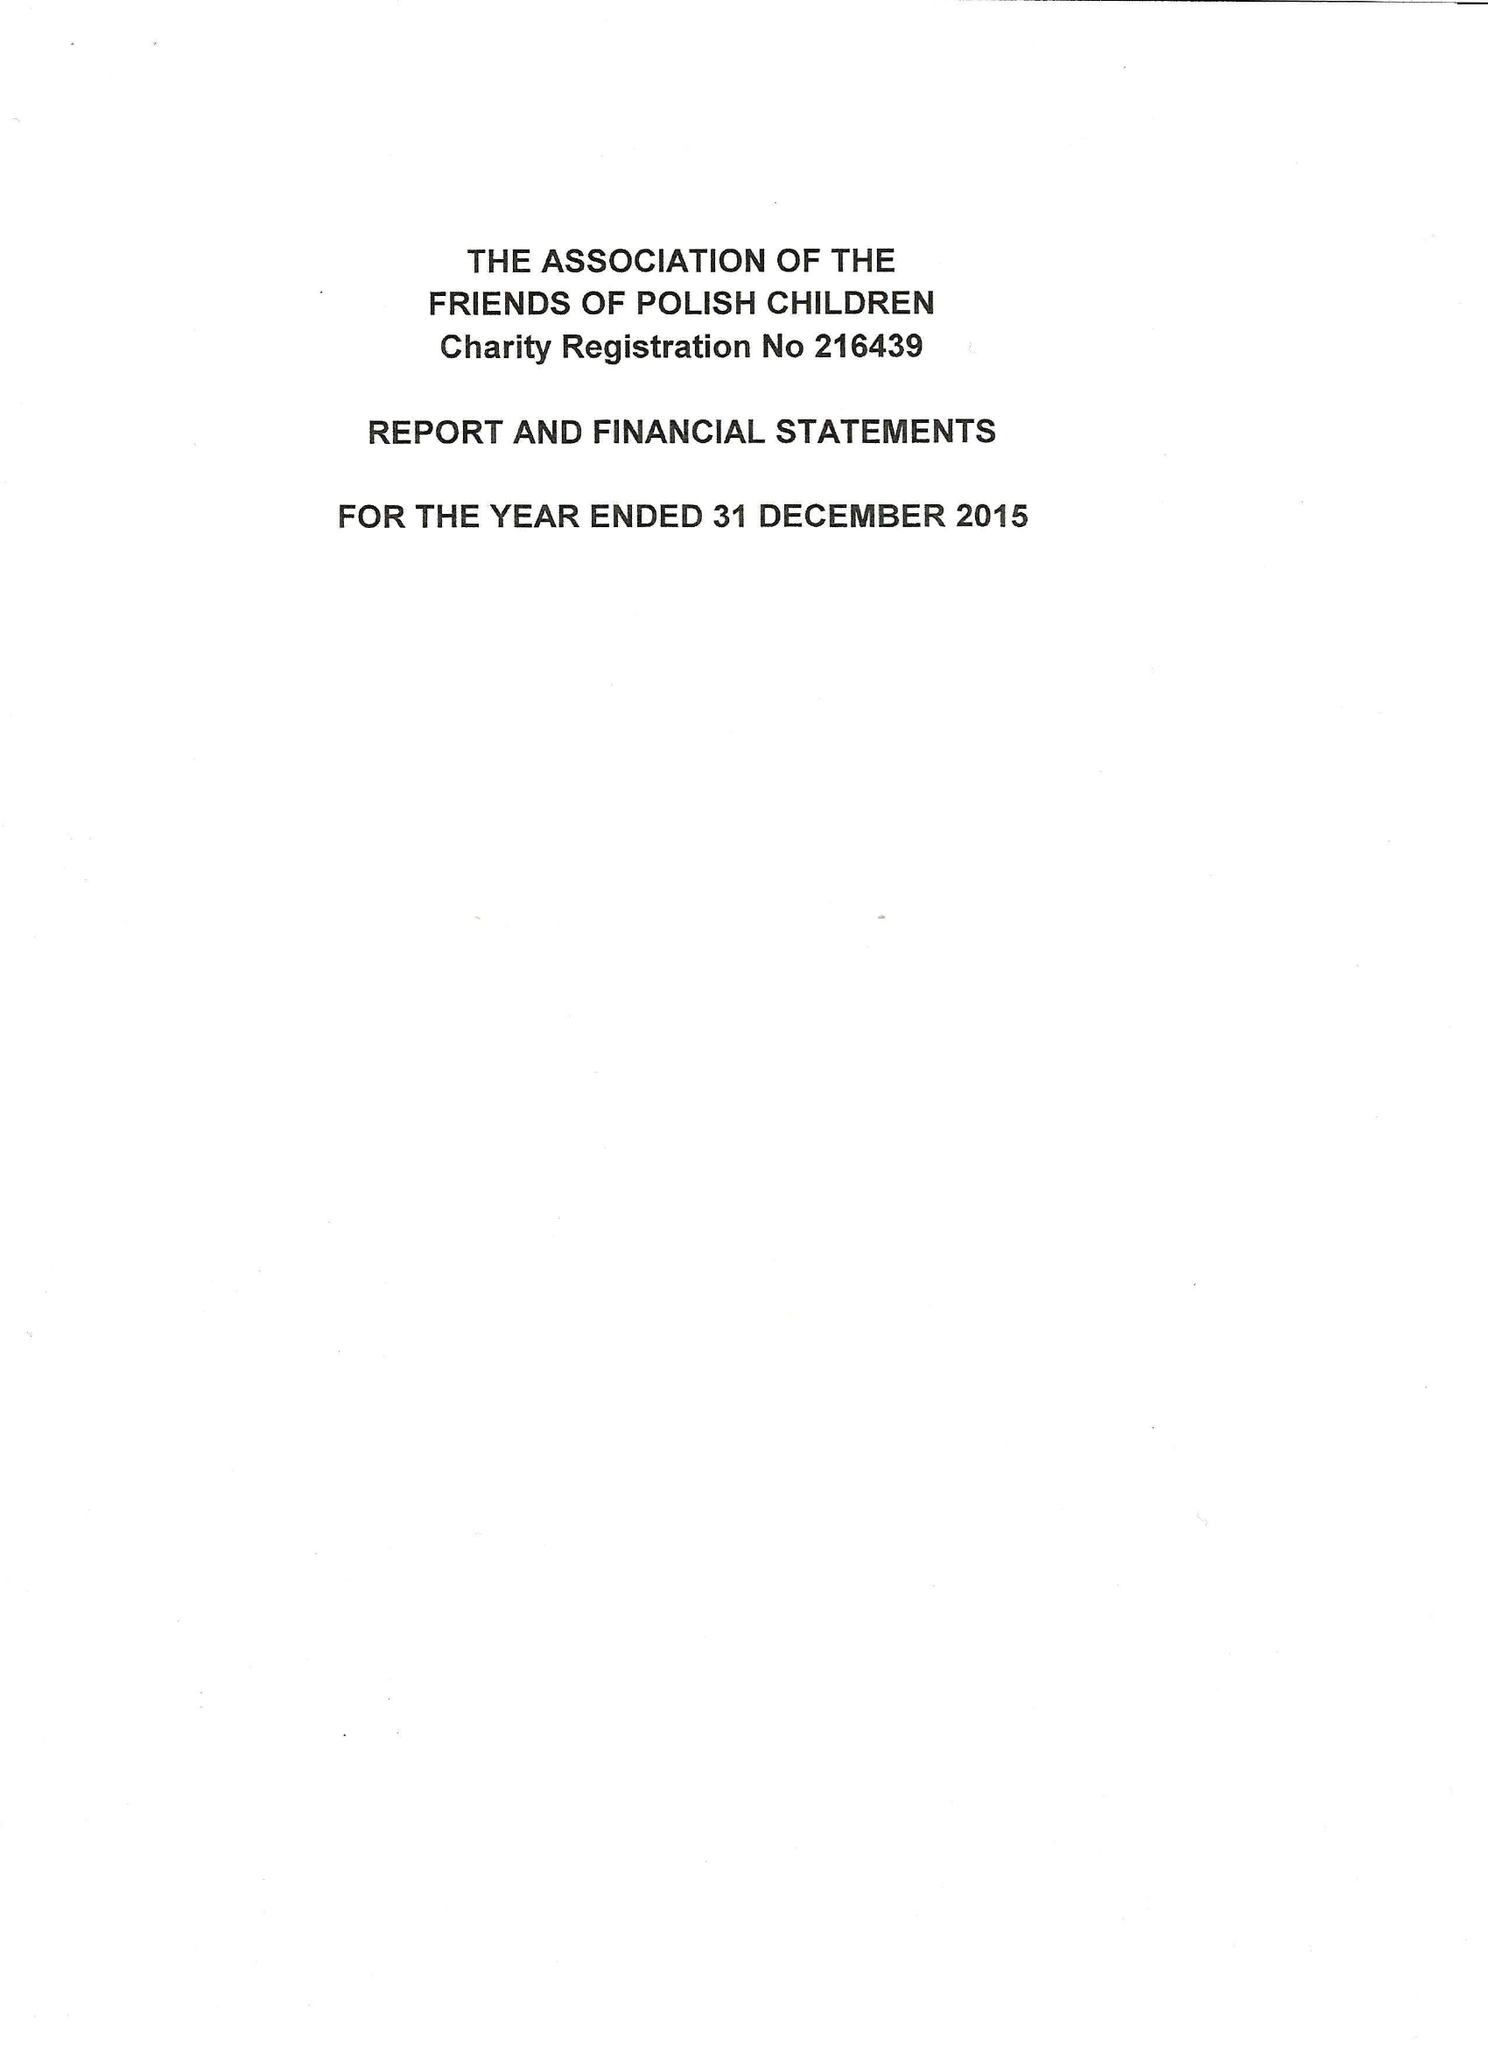What is the value for the report_date?
Answer the question using a single word or phrase. 2015-12-31 